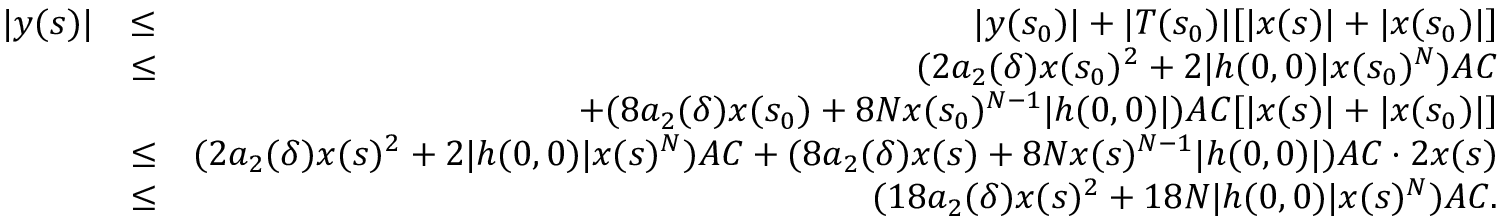Convert formula to latex. <formula><loc_0><loc_0><loc_500><loc_500>\begin{array} { r l r } { | y ( s ) | } & { \leq } & { | y ( s _ { 0 } ) | + | T ( s _ { 0 } ) | [ | x ( s ) | + | x ( s _ { 0 } ) | ] } \\ & { \leq } & { ( 2 a _ { 2 } ( \delta ) x ( s _ { 0 } ) ^ { 2 } + 2 | h ( 0 , 0 ) | x ( s _ { 0 } ) ^ { N } ) A C } \\ & { + ( 8 a _ { 2 } ( \delta ) x ( s _ { 0 } ) + 8 N x ( s _ { 0 } ) ^ { N - 1 } | h ( 0 , 0 ) | ) A C [ | x ( s ) | + | x ( s _ { 0 } ) | ] } \\ & { \leq } & { ( 2 a _ { 2 } ( \delta ) x ( s ) ^ { 2 } + 2 | h ( 0 , 0 ) | x ( s ) ^ { N } ) A C + ( 8 a _ { 2 } ( \delta ) x ( s ) + 8 N x ( s ) ^ { N - 1 } | h ( 0 , 0 ) | ) A C \cdot 2 x ( s ) } \\ & { \leq } & { ( 1 8 a _ { 2 } ( \delta ) x ( s ) ^ { 2 } + 1 8 N | h ( 0 , 0 ) | x ( s ) ^ { N } ) A C . } \end{array}</formula> 